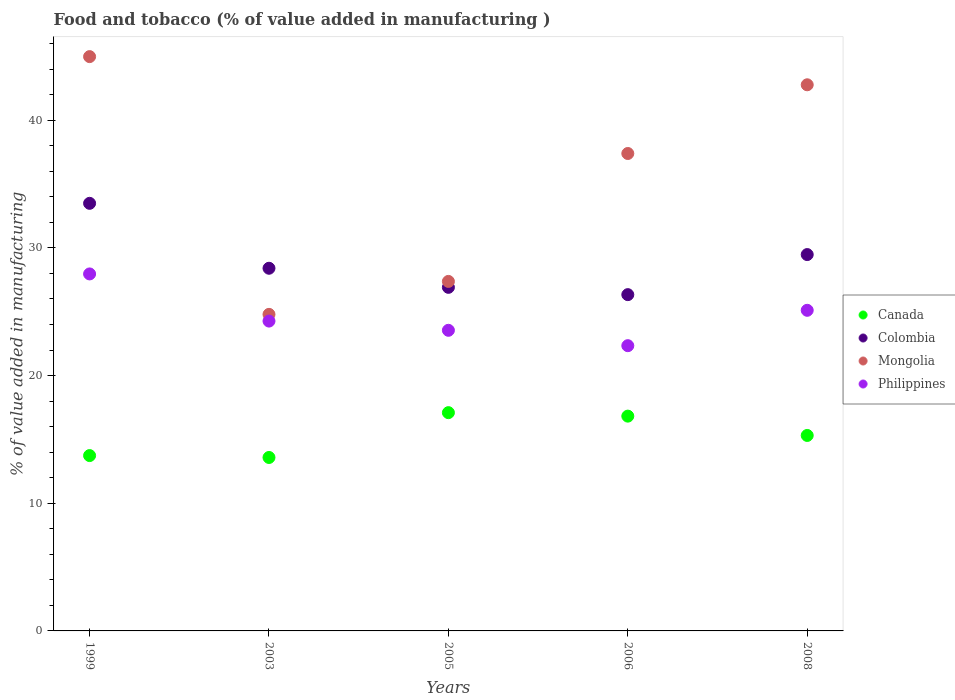What is the value added in manufacturing food and tobacco in Colombia in 2005?
Provide a succinct answer. 26.91. Across all years, what is the maximum value added in manufacturing food and tobacco in Mongolia?
Provide a short and direct response. 44.98. Across all years, what is the minimum value added in manufacturing food and tobacco in Canada?
Ensure brevity in your answer.  13.59. In which year was the value added in manufacturing food and tobacco in Philippines maximum?
Your response must be concise. 1999. In which year was the value added in manufacturing food and tobacco in Mongolia minimum?
Offer a terse response. 2003. What is the total value added in manufacturing food and tobacco in Colombia in the graph?
Provide a succinct answer. 144.63. What is the difference between the value added in manufacturing food and tobacco in Canada in 1999 and that in 2006?
Provide a succinct answer. -3.09. What is the difference between the value added in manufacturing food and tobacco in Philippines in 1999 and the value added in manufacturing food and tobacco in Mongolia in 2008?
Give a very brief answer. -14.82. What is the average value added in manufacturing food and tobacco in Canada per year?
Offer a terse response. 15.31. In the year 1999, what is the difference between the value added in manufacturing food and tobacco in Colombia and value added in manufacturing food and tobacco in Mongolia?
Keep it short and to the point. -11.49. What is the ratio of the value added in manufacturing food and tobacco in Mongolia in 1999 to that in 2005?
Your response must be concise. 1.64. Is the value added in manufacturing food and tobacco in Canada in 2003 less than that in 2005?
Provide a short and direct response. Yes. Is the difference between the value added in manufacturing food and tobacco in Colombia in 1999 and 2008 greater than the difference between the value added in manufacturing food and tobacco in Mongolia in 1999 and 2008?
Provide a succinct answer. Yes. What is the difference between the highest and the second highest value added in manufacturing food and tobacco in Mongolia?
Provide a short and direct response. 2.21. What is the difference between the highest and the lowest value added in manufacturing food and tobacco in Colombia?
Make the answer very short. 7.15. Is it the case that in every year, the sum of the value added in manufacturing food and tobacco in Canada and value added in manufacturing food and tobacco in Colombia  is greater than the sum of value added in manufacturing food and tobacco in Mongolia and value added in manufacturing food and tobacco in Philippines?
Your answer should be compact. No. Is the value added in manufacturing food and tobacco in Philippines strictly greater than the value added in manufacturing food and tobacco in Mongolia over the years?
Your response must be concise. No. Is the value added in manufacturing food and tobacco in Colombia strictly less than the value added in manufacturing food and tobacco in Philippines over the years?
Your response must be concise. No. How many dotlines are there?
Make the answer very short. 4. Does the graph contain any zero values?
Your answer should be very brief. No. What is the title of the graph?
Provide a succinct answer. Food and tobacco (% of value added in manufacturing ). What is the label or title of the Y-axis?
Your answer should be compact. % of value added in manufacturing. What is the % of value added in manufacturing of Canada in 1999?
Your response must be concise. 13.73. What is the % of value added in manufacturing in Colombia in 1999?
Your response must be concise. 33.49. What is the % of value added in manufacturing in Mongolia in 1999?
Give a very brief answer. 44.98. What is the % of value added in manufacturing in Philippines in 1999?
Provide a succinct answer. 27.96. What is the % of value added in manufacturing of Canada in 2003?
Your answer should be very brief. 13.59. What is the % of value added in manufacturing of Colombia in 2003?
Your response must be concise. 28.41. What is the % of value added in manufacturing in Mongolia in 2003?
Make the answer very short. 24.79. What is the % of value added in manufacturing of Philippines in 2003?
Your answer should be very brief. 24.27. What is the % of value added in manufacturing of Canada in 2005?
Your answer should be very brief. 17.1. What is the % of value added in manufacturing in Colombia in 2005?
Give a very brief answer. 26.91. What is the % of value added in manufacturing of Mongolia in 2005?
Your response must be concise. 27.38. What is the % of value added in manufacturing in Philippines in 2005?
Keep it short and to the point. 23.55. What is the % of value added in manufacturing in Canada in 2006?
Give a very brief answer. 16.82. What is the % of value added in manufacturing of Colombia in 2006?
Make the answer very short. 26.34. What is the % of value added in manufacturing in Mongolia in 2006?
Provide a succinct answer. 37.4. What is the % of value added in manufacturing in Philippines in 2006?
Offer a very short reply. 22.34. What is the % of value added in manufacturing of Canada in 2008?
Your response must be concise. 15.31. What is the % of value added in manufacturing in Colombia in 2008?
Your response must be concise. 29.48. What is the % of value added in manufacturing in Mongolia in 2008?
Give a very brief answer. 42.78. What is the % of value added in manufacturing in Philippines in 2008?
Give a very brief answer. 25.11. Across all years, what is the maximum % of value added in manufacturing of Canada?
Give a very brief answer. 17.1. Across all years, what is the maximum % of value added in manufacturing of Colombia?
Your answer should be very brief. 33.49. Across all years, what is the maximum % of value added in manufacturing in Mongolia?
Keep it short and to the point. 44.98. Across all years, what is the maximum % of value added in manufacturing of Philippines?
Your answer should be very brief. 27.96. Across all years, what is the minimum % of value added in manufacturing of Canada?
Your response must be concise. 13.59. Across all years, what is the minimum % of value added in manufacturing of Colombia?
Your answer should be very brief. 26.34. Across all years, what is the minimum % of value added in manufacturing in Mongolia?
Offer a terse response. 24.79. Across all years, what is the minimum % of value added in manufacturing in Philippines?
Your answer should be compact. 22.34. What is the total % of value added in manufacturing in Canada in the graph?
Ensure brevity in your answer.  76.55. What is the total % of value added in manufacturing in Colombia in the graph?
Your answer should be compact. 144.63. What is the total % of value added in manufacturing of Mongolia in the graph?
Give a very brief answer. 177.33. What is the total % of value added in manufacturing of Philippines in the graph?
Ensure brevity in your answer.  123.23. What is the difference between the % of value added in manufacturing in Canada in 1999 and that in 2003?
Offer a terse response. 0.15. What is the difference between the % of value added in manufacturing of Colombia in 1999 and that in 2003?
Your answer should be very brief. 5.09. What is the difference between the % of value added in manufacturing of Mongolia in 1999 and that in 2003?
Provide a succinct answer. 20.19. What is the difference between the % of value added in manufacturing in Philippines in 1999 and that in 2003?
Offer a very short reply. 3.69. What is the difference between the % of value added in manufacturing of Canada in 1999 and that in 2005?
Your response must be concise. -3.36. What is the difference between the % of value added in manufacturing of Colombia in 1999 and that in 2005?
Provide a short and direct response. 6.58. What is the difference between the % of value added in manufacturing of Mongolia in 1999 and that in 2005?
Your answer should be very brief. 17.61. What is the difference between the % of value added in manufacturing in Philippines in 1999 and that in 2005?
Your answer should be very brief. 4.42. What is the difference between the % of value added in manufacturing of Canada in 1999 and that in 2006?
Your answer should be very brief. -3.09. What is the difference between the % of value added in manufacturing in Colombia in 1999 and that in 2006?
Provide a succinct answer. 7.15. What is the difference between the % of value added in manufacturing in Mongolia in 1999 and that in 2006?
Provide a short and direct response. 7.59. What is the difference between the % of value added in manufacturing of Philippines in 1999 and that in 2006?
Keep it short and to the point. 5.62. What is the difference between the % of value added in manufacturing in Canada in 1999 and that in 2008?
Offer a very short reply. -1.58. What is the difference between the % of value added in manufacturing of Colombia in 1999 and that in 2008?
Give a very brief answer. 4.01. What is the difference between the % of value added in manufacturing in Mongolia in 1999 and that in 2008?
Keep it short and to the point. 2.21. What is the difference between the % of value added in manufacturing in Philippines in 1999 and that in 2008?
Provide a succinct answer. 2.85. What is the difference between the % of value added in manufacturing of Canada in 2003 and that in 2005?
Give a very brief answer. -3.51. What is the difference between the % of value added in manufacturing in Colombia in 2003 and that in 2005?
Provide a succinct answer. 1.49. What is the difference between the % of value added in manufacturing of Mongolia in 2003 and that in 2005?
Give a very brief answer. -2.58. What is the difference between the % of value added in manufacturing in Philippines in 2003 and that in 2005?
Your answer should be compact. 0.72. What is the difference between the % of value added in manufacturing of Canada in 2003 and that in 2006?
Your answer should be very brief. -3.24. What is the difference between the % of value added in manufacturing of Colombia in 2003 and that in 2006?
Ensure brevity in your answer.  2.07. What is the difference between the % of value added in manufacturing in Mongolia in 2003 and that in 2006?
Provide a succinct answer. -12.6. What is the difference between the % of value added in manufacturing in Philippines in 2003 and that in 2006?
Provide a succinct answer. 1.93. What is the difference between the % of value added in manufacturing in Canada in 2003 and that in 2008?
Provide a short and direct response. -1.73. What is the difference between the % of value added in manufacturing in Colombia in 2003 and that in 2008?
Give a very brief answer. -1.07. What is the difference between the % of value added in manufacturing of Mongolia in 2003 and that in 2008?
Give a very brief answer. -17.98. What is the difference between the % of value added in manufacturing in Philippines in 2003 and that in 2008?
Your answer should be compact. -0.84. What is the difference between the % of value added in manufacturing in Canada in 2005 and that in 2006?
Give a very brief answer. 0.27. What is the difference between the % of value added in manufacturing of Colombia in 2005 and that in 2006?
Your response must be concise. 0.57. What is the difference between the % of value added in manufacturing in Mongolia in 2005 and that in 2006?
Your answer should be compact. -10.02. What is the difference between the % of value added in manufacturing in Philippines in 2005 and that in 2006?
Your response must be concise. 1.2. What is the difference between the % of value added in manufacturing in Canada in 2005 and that in 2008?
Your answer should be very brief. 1.79. What is the difference between the % of value added in manufacturing in Colombia in 2005 and that in 2008?
Give a very brief answer. -2.57. What is the difference between the % of value added in manufacturing of Mongolia in 2005 and that in 2008?
Your answer should be very brief. -15.4. What is the difference between the % of value added in manufacturing of Philippines in 2005 and that in 2008?
Your response must be concise. -1.57. What is the difference between the % of value added in manufacturing in Canada in 2006 and that in 2008?
Your response must be concise. 1.51. What is the difference between the % of value added in manufacturing in Colombia in 2006 and that in 2008?
Your answer should be very brief. -3.14. What is the difference between the % of value added in manufacturing in Mongolia in 2006 and that in 2008?
Offer a terse response. -5.38. What is the difference between the % of value added in manufacturing of Philippines in 2006 and that in 2008?
Your answer should be very brief. -2.77. What is the difference between the % of value added in manufacturing in Canada in 1999 and the % of value added in manufacturing in Colombia in 2003?
Your answer should be very brief. -14.67. What is the difference between the % of value added in manufacturing in Canada in 1999 and the % of value added in manufacturing in Mongolia in 2003?
Offer a terse response. -11.06. What is the difference between the % of value added in manufacturing in Canada in 1999 and the % of value added in manufacturing in Philippines in 2003?
Offer a terse response. -10.53. What is the difference between the % of value added in manufacturing of Colombia in 1999 and the % of value added in manufacturing of Mongolia in 2003?
Provide a succinct answer. 8.7. What is the difference between the % of value added in manufacturing in Colombia in 1999 and the % of value added in manufacturing in Philippines in 2003?
Provide a succinct answer. 9.22. What is the difference between the % of value added in manufacturing in Mongolia in 1999 and the % of value added in manufacturing in Philippines in 2003?
Give a very brief answer. 20.71. What is the difference between the % of value added in manufacturing of Canada in 1999 and the % of value added in manufacturing of Colombia in 2005?
Offer a very short reply. -13.18. What is the difference between the % of value added in manufacturing in Canada in 1999 and the % of value added in manufacturing in Mongolia in 2005?
Provide a short and direct response. -13.64. What is the difference between the % of value added in manufacturing of Canada in 1999 and the % of value added in manufacturing of Philippines in 2005?
Make the answer very short. -9.81. What is the difference between the % of value added in manufacturing in Colombia in 1999 and the % of value added in manufacturing in Mongolia in 2005?
Provide a succinct answer. 6.12. What is the difference between the % of value added in manufacturing of Colombia in 1999 and the % of value added in manufacturing of Philippines in 2005?
Your answer should be compact. 9.95. What is the difference between the % of value added in manufacturing of Mongolia in 1999 and the % of value added in manufacturing of Philippines in 2005?
Offer a very short reply. 21.44. What is the difference between the % of value added in manufacturing in Canada in 1999 and the % of value added in manufacturing in Colombia in 2006?
Your answer should be very brief. -12.61. What is the difference between the % of value added in manufacturing of Canada in 1999 and the % of value added in manufacturing of Mongolia in 2006?
Make the answer very short. -23.66. What is the difference between the % of value added in manufacturing in Canada in 1999 and the % of value added in manufacturing in Philippines in 2006?
Make the answer very short. -8.61. What is the difference between the % of value added in manufacturing in Colombia in 1999 and the % of value added in manufacturing in Mongolia in 2006?
Your response must be concise. -3.9. What is the difference between the % of value added in manufacturing of Colombia in 1999 and the % of value added in manufacturing of Philippines in 2006?
Make the answer very short. 11.15. What is the difference between the % of value added in manufacturing of Mongolia in 1999 and the % of value added in manufacturing of Philippines in 2006?
Your answer should be compact. 22.64. What is the difference between the % of value added in manufacturing of Canada in 1999 and the % of value added in manufacturing of Colombia in 2008?
Offer a terse response. -15.74. What is the difference between the % of value added in manufacturing of Canada in 1999 and the % of value added in manufacturing of Mongolia in 2008?
Keep it short and to the point. -29.04. What is the difference between the % of value added in manufacturing in Canada in 1999 and the % of value added in manufacturing in Philippines in 2008?
Ensure brevity in your answer.  -11.38. What is the difference between the % of value added in manufacturing of Colombia in 1999 and the % of value added in manufacturing of Mongolia in 2008?
Offer a very short reply. -9.29. What is the difference between the % of value added in manufacturing of Colombia in 1999 and the % of value added in manufacturing of Philippines in 2008?
Your answer should be compact. 8.38. What is the difference between the % of value added in manufacturing of Mongolia in 1999 and the % of value added in manufacturing of Philippines in 2008?
Ensure brevity in your answer.  19.87. What is the difference between the % of value added in manufacturing in Canada in 2003 and the % of value added in manufacturing in Colombia in 2005?
Your answer should be very brief. -13.33. What is the difference between the % of value added in manufacturing of Canada in 2003 and the % of value added in manufacturing of Mongolia in 2005?
Provide a succinct answer. -13.79. What is the difference between the % of value added in manufacturing in Canada in 2003 and the % of value added in manufacturing in Philippines in 2005?
Offer a terse response. -9.96. What is the difference between the % of value added in manufacturing in Colombia in 2003 and the % of value added in manufacturing in Mongolia in 2005?
Offer a very short reply. 1.03. What is the difference between the % of value added in manufacturing of Colombia in 2003 and the % of value added in manufacturing of Philippines in 2005?
Offer a very short reply. 4.86. What is the difference between the % of value added in manufacturing in Mongolia in 2003 and the % of value added in manufacturing in Philippines in 2005?
Provide a short and direct response. 1.25. What is the difference between the % of value added in manufacturing of Canada in 2003 and the % of value added in manufacturing of Colombia in 2006?
Give a very brief answer. -12.75. What is the difference between the % of value added in manufacturing of Canada in 2003 and the % of value added in manufacturing of Mongolia in 2006?
Offer a terse response. -23.81. What is the difference between the % of value added in manufacturing in Canada in 2003 and the % of value added in manufacturing in Philippines in 2006?
Offer a very short reply. -8.76. What is the difference between the % of value added in manufacturing in Colombia in 2003 and the % of value added in manufacturing in Mongolia in 2006?
Offer a very short reply. -8.99. What is the difference between the % of value added in manufacturing in Colombia in 2003 and the % of value added in manufacturing in Philippines in 2006?
Offer a very short reply. 6.06. What is the difference between the % of value added in manufacturing of Mongolia in 2003 and the % of value added in manufacturing of Philippines in 2006?
Offer a very short reply. 2.45. What is the difference between the % of value added in manufacturing of Canada in 2003 and the % of value added in manufacturing of Colombia in 2008?
Ensure brevity in your answer.  -15.89. What is the difference between the % of value added in manufacturing of Canada in 2003 and the % of value added in manufacturing of Mongolia in 2008?
Provide a succinct answer. -29.19. What is the difference between the % of value added in manufacturing of Canada in 2003 and the % of value added in manufacturing of Philippines in 2008?
Your answer should be compact. -11.53. What is the difference between the % of value added in manufacturing in Colombia in 2003 and the % of value added in manufacturing in Mongolia in 2008?
Provide a short and direct response. -14.37. What is the difference between the % of value added in manufacturing in Colombia in 2003 and the % of value added in manufacturing in Philippines in 2008?
Offer a terse response. 3.29. What is the difference between the % of value added in manufacturing of Mongolia in 2003 and the % of value added in manufacturing of Philippines in 2008?
Make the answer very short. -0.32. What is the difference between the % of value added in manufacturing in Canada in 2005 and the % of value added in manufacturing in Colombia in 2006?
Provide a short and direct response. -9.24. What is the difference between the % of value added in manufacturing in Canada in 2005 and the % of value added in manufacturing in Mongolia in 2006?
Make the answer very short. -20.3. What is the difference between the % of value added in manufacturing of Canada in 2005 and the % of value added in manufacturing of Philippines in 2006?
Provide a succinct answer. -5.25. What is the difference between the % of value added in manufacturing in Colombia in 2005 and the % of value added in manufacturing in Mongolia in 2006?
Provide a succinct answer. -10.48. What is the difference between the % of value added in manufacturing in Colombia in 2005 and the % of value added in manufacturing in Philippines in 2006?
Your answer should be compact. 4.57. What is the difference between the % of value added in manufacturing of Mongolia in 2005 and the % of value added in manufacturing of Philippines in 2006?
Offer a very short reply. 5.03. What is the difference between the % of value added in manufacturing in Canada in 2005 and the % of value added in manufacturing in Colombia in 2008?
Give a very brief answer. -12.38. What is the difference between the % of value added in manufacturing in Canada in 2005 and the % of value added in manufacturing in Mongolia in 2008?
Give a very brief answer. -25.68. What is the difference between the % of value added in manufacturing in Canada in 2005 and the % of value added in manufacturing in Philippines in 2008?
Your answer should be compact. -8.02. What is the difference between the % of value added in manufacturing in Colombia in 2005 and the % of value added in manufacturing in Mongolia in 2008?
Provide a short and direct response. -15.87. What is the difference between the % of value added in manufacturing in Colombia in 2005 and the % of value added in manufacturing in Philippines in 2008?
Keep it short and to the point. 1.8. What is the difference between the % of value added in manufacturing of Mongolia in 2005 and the % of value added in manufacturing of Philippines in 2008?
Your answer should be compact. 2.26. What is the difference between the % of value added in manufacturing of Canada in 2006 and the % of value added in manufacturing of Colombia in 2008?
Your answer should be compact. -12.65. What is the difference between the % of value added in manufacturing in Canada in 2006 and the % of value added in manufacturing in Mongolia in 2008?
Keep it short and to the point. -25.95. What is the difference between the % of value added in manufacturing in Canada in 2006 and the % of value added in manufacturing in Philippines in 2008?
Ensure brevity in your answer.  -8.29. What is the difference between the % of value added in manufacturing in Colombia in 2006 and the % of value added in manufacturing in Mongolia in 2008?
Make the answer very short. -16.44. What is the difference between the % of value added in manufacturing of Colombia in 2006 and the % of value added in manufacturing of Philippines in 2008?
Your answer should be very brief. 1.23. What is the difference between the % of value added in manufacturing of Mongolia in 2006 and the % of value added in manufacturing of Philippines in 2008?
Make the answer very short. 12.28. What is the average % of value added in manufacturing in Canada per year?
Your response must be concise. 15.31. What is the average % of value added in manufacturing in Colombia per year?
Give a very brief answer. 28.93. What is the average % of value added in manufacturing in Mongolia per year?
Make the answer very short. 35.47. What is the average % of value added in manufacturing in Philippines per year?
Make the answer very short. 24.65. In the year 1999, what is the difference between the % of value added in manufacturing in Canada and % of value added in manufacturing in Colombia?
Ensure brevity in your answer.  -19.76. In the year 1999, what is the difference between the % of value added in manufacturing in Canada and % of value added in manufacturing in Mongolia?
Keep it short and to the point. -31.25. In the year 1999, what is the difference between the % of value added in manufacturing of Canada and % of value added in manufacturing of Philippines?
Provide a short and direct response. -14.23. In the year 1999, what is the difference between the % of value added in manufacturing in Colombia and % of value added in manufacturing in Mongolia?
Offer a very short reply. -11.49. In the year 1999, what is the difference between the % of value added in manufacturing in Colombia and % of value added in manufacturing in Philippines?
Ensure brevity in your answer.  5.53. In the year 1999, what is the difference between the % of value added in manufacturing in Mongolia and % of value added in manufacturing in Philippines?
Offer a terse response. 17.02. In the year 2003, what is the difference between the % of value added in manufacturing in Canada and % of value added in manufacturing in Colombia?
Offer a terse response. -14.82. In the year 2003, what is the difference between the % of value added in manufacturing of Canada and % of value added in manufacturing of Mongolia?
Give a very brief answer. -11.21. In the year 2003, what is the difference between the % of value added in manufacturing in Canada and % of value added in manufacturing in Philippines?
Your answer should be very brief. -10.68. In the year 2003, what is the difference between the % of value added in manufacturing of Colombia and % of value added in manufacturing of Mongolia?
Your answer should be very brief. 3.61. In the year 2003, what is the difference between the % of value added in manufacturing of Colombia and % of value added in manufacturing of Philippines?
Provide a short and direct response. 4.14. In the year 2003, what is the difference between the % of value added in manufacturing of Mongolia and % of value added in manufacturing of Philippines?
Your answer should be compact. 0.53. In the year 2005, what is the difference between the % of value added in manufacturing in Canada and % of value added in manufacturing in Colombia?
Provide a succinct answer. -9.82. In the year 2005, what is the difference between the % of value added in manufacturing in Canada and % of value added in manufacturing in Mongolia?
Ensure brevity in your answer.  -10.28. In the year 2005, what is the difference between the % of value added in manufacturing of Canada and % of value added in manufacturing of Philippines?
Your response must be concise. -6.45. In the year 2005, what is the difference between the % of value added in manufacturing of Colombia and % of value added in manufacturing of Mongolia?
Your answer should be very brief. -0.46. In the year 2005, what is the difference between the % of value added in manufacturing of Colombia and % of value added in manufacturing of Philippines?
Offer a terse response. 3.37. In the year 2005, what is the difference between the % of value added in manufacturing of Mongolia and % of value added in manufacturing of Philippines?
Your answer should be very brief. 3.83. In the year 2006, what is the difference between the % of value added in manufacturing of Canada and % of value added in manufacturing of Colombia?
Your answer should be compact. -9.52. In the year 2006, what is the difference between the % of value added in manufacturing of Canada and % of value added in manufacturing of Mongolia?
Provide a short and direct response. -20.57. In the year 2006, what is the difference between the % of value added in manufacturing of Canada and % of value added in manufacturing of Philippines?
Provide a short and direct response. -5.52. In the year 2006, what is the difference between the % of value added in manufacturing in Colombia and % of value added in manufacturing in Mongolia?
Offer a very short reply. -11.06. In the year 2006, what is the difference between the % of value added in manufacturing of Colombia and % of value added in manufacturing of Philippines?
Offer a very short reply. 4. In the year 2006, what is the difference between the % of value added in manufacturing in Mongolia and % of value added in manufacturing in Philippines?
Your answer should be compact. 15.05. In the year 2008, what is the difference between the % of value added in manufacturing in Canada and % of value added in manufacturing in Colombia?
Provide a succinct answer. -14.17. In the year 2008, what is the difference between the % of value added in manufacturing in Canada and % of value added in manufacturing in Mongolia?
Your answer should be very brief. -27.47. In the year 2008, what is the difference between the % of value added in manufacturing of Canada and % of value added in manufacturing of Philippines?
Make the answer very short. -9.8. In the year 2008, what is the difference between the % of value added in manufacturing of Colombia and % of value added in manufacturing of Mongolia?
Your answer should be compact. -13.3. In the year 2008, what is the difference between the % of value added in manufacturing of Colombia and % of value added in manufacturing of Philippines?
Your answer should be very brief. 4.37. In the year 2008, what is the difference between the % of value added in manufacturing of Mongolia and % of value added in manufacturing of Philippines?
Give a very brief answer. 17.66. What is the ratio of the % of value added in manufacturing of Canada in 1999 to that in 2003?
Your response must be concise. 1.01. What is the ratio of the % of value added in manufacturing of Colombia in 1999 to that in 2003?
Keep it short and to the point. 1.18. What is the ratio of the % of value added in manufacturing in Mongolia in 1999 to that in 2003?
Make the answer very short. 1.81. What is the ratio of the % of value added in manufacturing of Philippines in 1999 to that in 2003?
Offer a very short reply. 1.15. What is the ratio of the % of value added in manufacturing in Canada in 1999 to that in 2005?
Your answer should be compact. 0.8. What is the ratio of the % of value added in manufacturing of Colombia in 1999 to that in 2005?
Make the answer very short. 1.24. What is the ratio of the % of value added in manufacturing of Mongolia in 1999 to that in 2005?
Your response must be concise. 1.64. What is the ratio of the % of value added in manufacturing of Philippines in 1999 to that in 2005?
Make the answer very short. 1.19. What is the ratio of the % of value added in manufacturing of Canada in 1999 to that in 2006?
Make the answer very short. 0.82. What is the ratio of the % of value added in manufacturing in Colombia in 1999 to that in 2006?
Make the answer very short. 1.27. What is the ratio of the % of value added in manufacturing in Mongolia in 1999 to that in 2006?
Your answer should be compact. 1.2. What is the ratio of the % of value added in manufacturing of Philippines in 1999 to that in 2006?
Give a very brief answer. 1.25. What is the ratio of the % of value added in manufacturing in Canada in 1999 to that in 2008?
Ensure brevity in your answer.  0.9. What is the ratio of the % of value added in manufacturing in Colombia in 1999 to that in 2008?
Provide a short and direct response. 1.14. What is the ratio of the % of value added in manufacturing of Mongolia in 1999 to that in 2008?
Your answer should be very brief. 1.05. What is the ratio of the % of value added in manufacturing of Philippines in 1999 to that in 2008?
Give a very brief answer. 1.11. What is the ratio of the % of value added in manufacturing of Canada in 2003 to that in 2005?
Provide a short and direct response. 0.79. What is the ratio of the % of value added in manufacturing in Colombia in 2003 to that in 2005?
Your response must be concise. 1.06. What is the ratio of the % of value added in manufacturing of Mongolia in 2003 to that in 2005?
Your answer should be very brief. 0.91. What is the ratio of the % of value added in manufacturing of Philippines in 2003 to that in 2005?
Give a very brief answer. 1.03. What is the ratio of the % of value added in manufacturing in Canada in 2003 to that in 2006?
Keep it short and to the point. 0.81. What is the ratio of the % of value added in manufacturing in Colombia in 2003 to that in 2006?
Offer a terse response. 1.08. What is the ratio of the % of value added in manufacturing of Mongolia in 2003 to that in 2006?
Keep it short and to the point. 0.66. What is the ratio of the % of value added in manufacturing of Philippines in 2003 to that in 2006?
Your response must be concise. 1.09. What is the ratio of the % of value added in manufacturing in Canada in 2003 to that in 2008?
Your answer should be very brief. 0.89. What is the ratio of the % of value added in manufacturing in Colombia in 2003 to that in 2008?
Your answer should be compact. 0.96. What is the ratio of the % of value added in manufacturing of Mongolia in 2003 to that in 2008?
Provide a short and direct response. 0.58. What is the ratio of the % of value added in manufacturing in Philippines in 2003 to that in 2008?
Provide a succinct answer. 0.97. What is the ratio of the % of value added in manufacturing of Canada in 2005 to that in 2006?
Your response must be concise. 1.02. What is the ratio of the % of value added in manufacturing in Colombia in 2005 to that in 2006?
Your answer should be very brief. 1.02. What is the ratio of the % of value added in manufacturing in Mongolia in 2005 to that in 2006?
Your answer should be very brief. 0.73. What is the ratio of the % of value added in manufacturing in Philippines in 2005 to that in 2006?
Ensure brevity in your answer.  1.05. What is the ratio of the % of value added in manufacturing in Canada in 2005 to that in 2008?
Your answer should be very brief. 1.12. What is the ratio of the % of value added in manufacturing of Colombia in 2005 to that in 2008?
Your response must be concise. 0.91. What is the ratio of the % of value added in manufacturing of Mongolia in 2005 to that in 2008?
Your answer should be compact. 0.64. What is the ratio of the % of value added in manufacturing in Philippines in 2005 to that in 2008?
Your response must be concise. 0.94. What is the ratio of the % of value added in manufacturing in Canada in 2006 to that in 2008?
Offer a very short reply. 1.1. What is the ratio of the % of value added in manufacturing of Colombia in 2006 to that in 2008?
Make the answer very short. 0.89. What is the ratio of the % of value added in manufacturing in Mongolia in 2006 to that in 2008?
Your answer should be very brief. 0.87. What is the ratio of the % of value added in manufacturing in Philippines in 2006 to that in 2008?
Offer a terse response. 0.89. What is the difference between the highest and the second highest % of value added in manufacturing in Canada?
Offer a terse response. 0.27. What is the difference between the highest and the second highest % of value added in manufacturing of Colombia?
Give a very brief answer. 4.01. What is the difference between the highest and the second highest % of value added in manufacturing of Mongolia?
Provide a succinct answer. 2.21. What is the difference between the highest and the second highest % of value added in manufacturing in Philippines?
Your answer should be very brief. 2.85. What is the difference between the highest and the lowest % of value added in manufacturing in Canada?
Keep it short and to the point. 3.51. What is the difference between the highest and the lowest % of value added in manufacturing in Colombia?
Offer a very short reply. 7.15. What is the difference between the highest and the lowest % of value added in manufacturing of Mongolia?
Offer a very short reply. 20.19. What is the difference between the highest and the lowest % of value added in manufacturing in Philippines?
Provide a succinct answer. 5.62. 